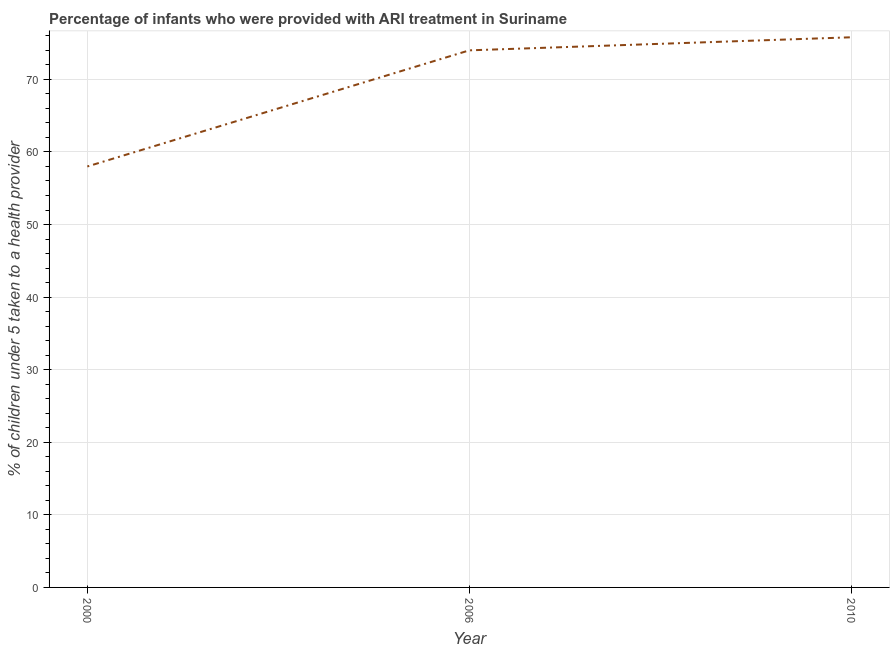What is the percentage of children who were provided with ari treatment in 2000?
Offer a terse response. 58. Across all years, what is the maximum percentage of children who were provided with ari treatment?
Provide a succinct answer. 75.8. In which year was the percentage of children who were provided with ari treatment maximum?
Provide a short and direct response. 2010. In which year was the percentage of children who were provided with ari treatment minimum?
Your answer should be compact. 2000. What is the sum of the percentage of children who were provided with ari treatment?
Give a very brief answer. 207.8. What is the difference between the percentage of children who were provided with ari treatment in 2006 and 2010?
Your response must be concise. -1.8. What is the average percentage of children who were provided with ari treatment per year?
Your answer should be compact. 69.27. In how many years, is the percentage of children who were provided with ari treatment greater than 20 %?
Offer a very short reply. 3. Do a majority of the years between 2006 and 2000 (inclusive) have percentage of children who were provided with ari treatment greater than 64 %?
Make the answer very short. No. What is the ratio of the percentage of children who were provided with ari treatment in 2000 to that in 2006?
Keep it short and to the point. 0.78. Is the percentage of children who were provided with ari treatment in 2000 less than that in 2006?
Ensure brevity in your answer.  Yes. Is the difference between the percentage of children who were provided with ari treatment in 2000 and 2010 greater than the difference between any two years?
Provide a succinct answer. Yes. What is the difference between the highest and the second highest percentage of children who were provided with ari treatment?
Your response must be concise. 1.8. What is the difference between the highest and the lowest percentage of children who were provided with ari treatment?
Your response must be concise. 17.8. Does the percentage of children who were provided with ari treatment monotonically increase over the years?
Ensure brevity in your answer.  Yes. How many years are there in the graph?
Provide a short and direct response. 3. What is the difference between two consecutive major ticks on the Y-axis?
Make the answer very short. 10. Are the values on the major ticks of Y-axis written in scientific E-notation?
Your response must be concise. No. Does the graph contain any zero values?
Provide a short and direct response. No. Does the graph contain grids?
Give a very brief answer. Yes. What is the title of the graph?
Make the answer very short. Percentage of infants who were provided with ARI treatment in Suriname. What is the label or title of the X-axis?
Offer a terse response. Year. What is the label or title of the Y-axis?
Keep it short and to the point. % of children under 5 taken to a health provider. What is the % of children under 5 taken to a health provider of 2006?
Make the answer very short. 74. What is the % of children under 5 taken to a health provider in 2010?
Offer a terse response. 75.8. What is the difference between the % of children under 5 taken to a health provider in 2000 and 2006?
Offer a very short reply. -16. What is the difference between the % of children under 5 taken to a health provider in 2000 and 2010?
Make the answer very short. -17.8. What is the ratio of the % of children under 5 taken to a health provider in 2000 to that in 2006?
Make the answer very short. 0.78. What is the ratio of the % of children under 5 taken to a health provider in 2000 to that in 2010?
Make the answer very short. 0.77. 